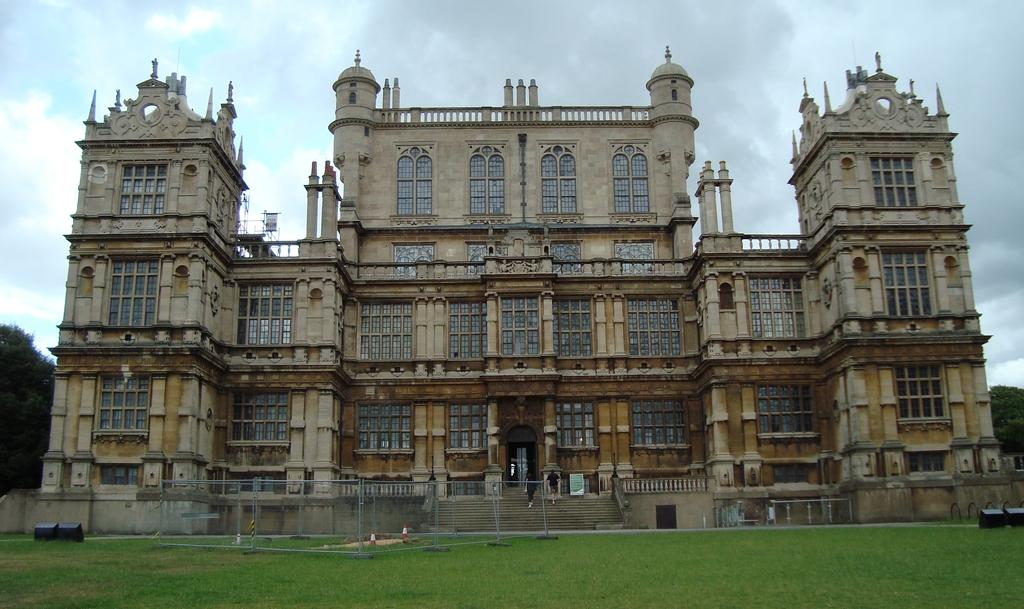What can be seen in the background of the image? The sky is visible in the background of the image. What type of structure is present in the image? There is a building in the image. What type of vegetation is present in the image? Trees and grass are visible in the image. Are there any living beings in the image? Yes, there are people in the image. What additional objects can be seen in the image? There is a board, a mesh, stairs, railings, and other objects in the image. What type of caption is written on the board in the image? There is no caption written on the board in the image; it is just a plain board. 